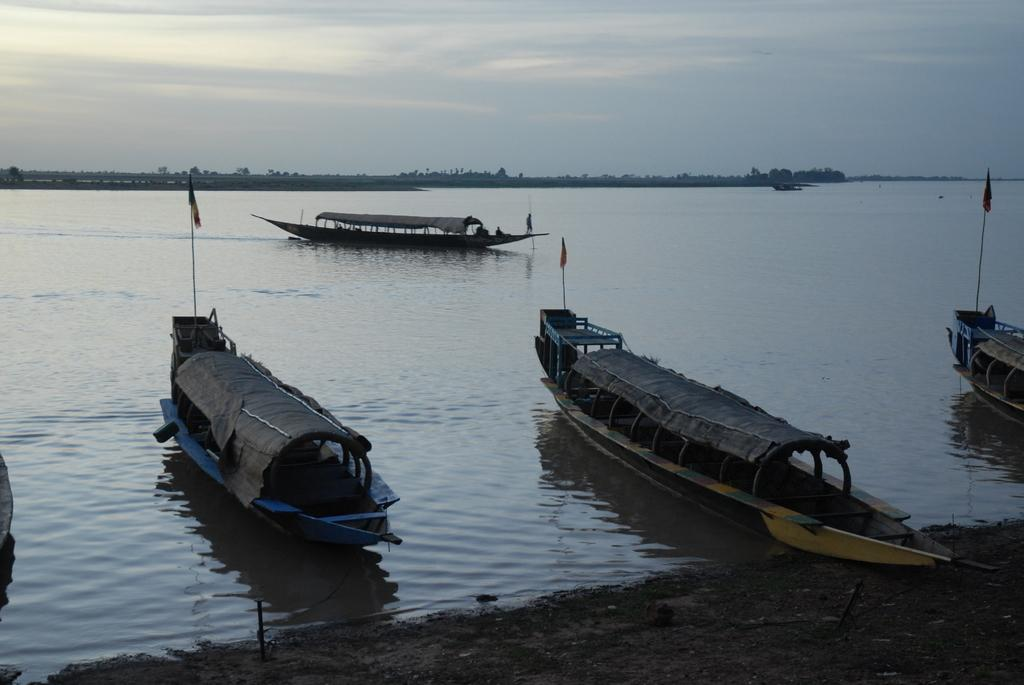How many boats are in the image? There are four small boats in the image. Where are the boats located? The boats are in the river water. What can be seen in the background of the image? There are trees visible in the background of the image. What is visible at the top of the image? The sky is visible at the top of the image. What type of loaf is being used as a paddle for one of the boats in the image? There is no loaf present in the image, and the boats are not using any unconventional objects as paddles. 